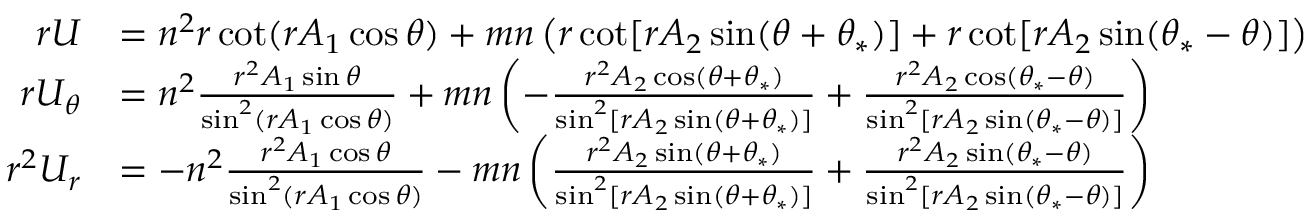Convert formula to latex. <formula><loc_0><loc_0><loc_500><loc_500>\begin{array} { r l } { r U } & { = n ^ { 2 } r \cot ( r A _ { 1 } \cos \theta ) + m n \left ( r \cot [ r A _ { 2 } \sin ( \theta + \theta _ { * } ) ] + r \cot [ r A _ { 2 } \sin ( \theta _ { * } - \theta ) ] \right ) } \\ { r U _ { \theta } } & { = n ^ { 2 } \frac { r ^ { 2 } A _ { 1 } \sin \theta } { \sin ^ { 2 } ( r A _ { 1 } \cos \theta ) } + m n \left ( - \frac { r ^ { 2 } A _ { 2 } \cos ( \theta + \theta _ { * } ) } { \sin ^ { 2 } [ r A _ { 2 } \sin ( \theta + \theta _ { * } ) ] } + \frac { r ^ { 2 } A _ { 2 } \cos ( \theta _ { * } - \theta ) } { \sin ^ { 2 } [ r A _ { 2 } \sin ( \theta _ { * } - \theta ) ] } \right ) } \\ { r ^ { 2 } U _ { r } } & { = - n ^ { 2 } \frac { r ^ { 2 } A _ { 1 } \cos \theta } { \sin ^ { 2 } ( r A _ { 1 } \cos \theta ) } - m n \left ( \frac { r ^ { 2 } A _ { 2 } \sin ( \theta + \theta _ { * } ) } { \sin ^ { 2 } [ r A _ { 2 } \sin ( \theta + \theta _ { * } ) ] } + \frac { r ^ { 2 } A _ { 2 } \sin ( \theta _ { * } - \theta ) } { \sin ^ { 2 } [ r A _ { 2 } \sin ( \theta _ { * } - \theta ) ] } \right ) } \end{array}</formula> 